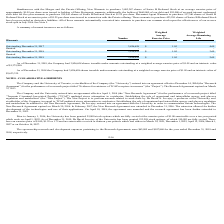According to Protagenic Therapeutics's financial document, What is the weighted average remaining life of the outstanding warrants as at December 31, 2017? According to the financial document, 4.69. The relevant text states: "Outstanding December 31, 2017 3,826,658 $ 1.05 4.69..." Also, What is the weighted average remaining life of the outstanding warrants as at December 31, 2018? According to the financial document, 3.69. The relevant text states: "Outstanding December 31, 2018 3,826,658 $ 1.05 3.69..." Also, What is the weighted average remaining life of the outstanding warrants as at December 31, 2019? According to the financial document, 2.69. The relevant text states: "Outstanding December 31, 2019 3,826,658 $ 1.05 2.69..." Also, can you calculate: What is the percentage change in the number of outstanding shares at December 31, 2018 and December 31, 2019? I cannot find a specific answer to this question in the financial document. Also, can you calculate: What is the difference in the number of outstanding shares as at December 31, 2017 and 2018? I cannot find a specific answer to this question in the financial document. Also, can you calculate: Using the intrinsic value of the company's shares issuable under warrants, what is the value of each share? Based on the calculation: 3,633,335/3,826,658 , the result is 0.95. This is based on the information: "Outstanding December 31, 2017 3,826,658 $ 1.05 4.69 $3,633,335. Outstanding December 31, 2017 3,826,658 $ 1.05 4.69..." The key data points involved are: 3,633,335, 3,826,658. 